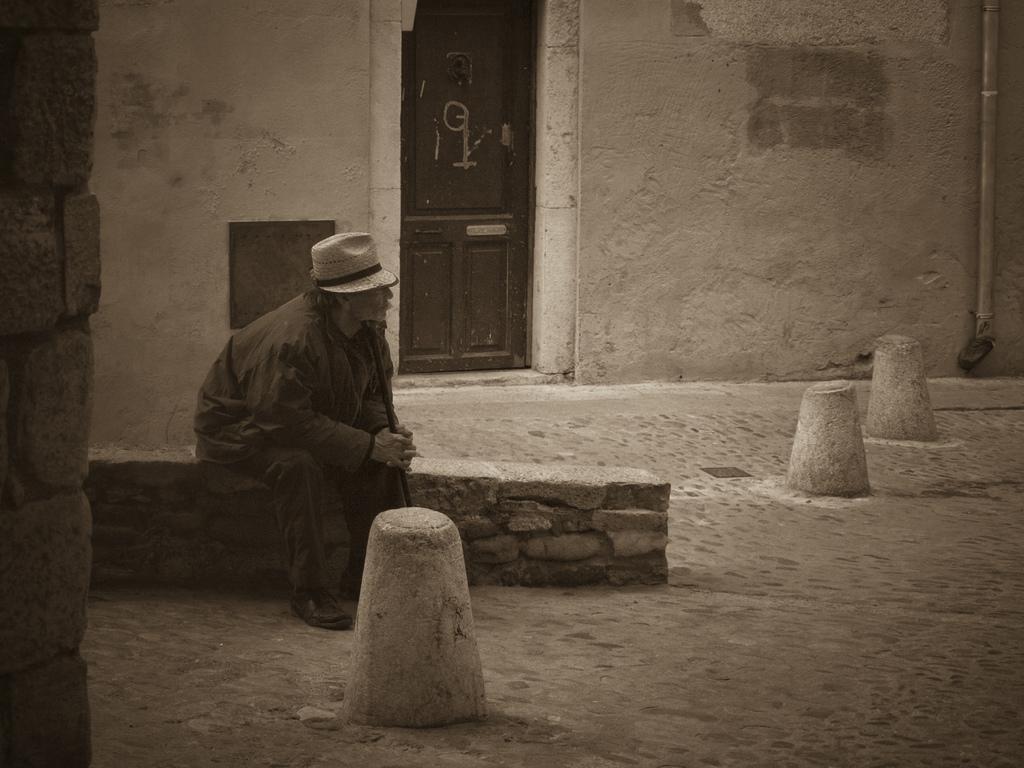Could you give a brief overview of what you see in this image? In this picture we can see a man is seated and he wore a cap, in the background we can see a door and a pipe on the wall. 